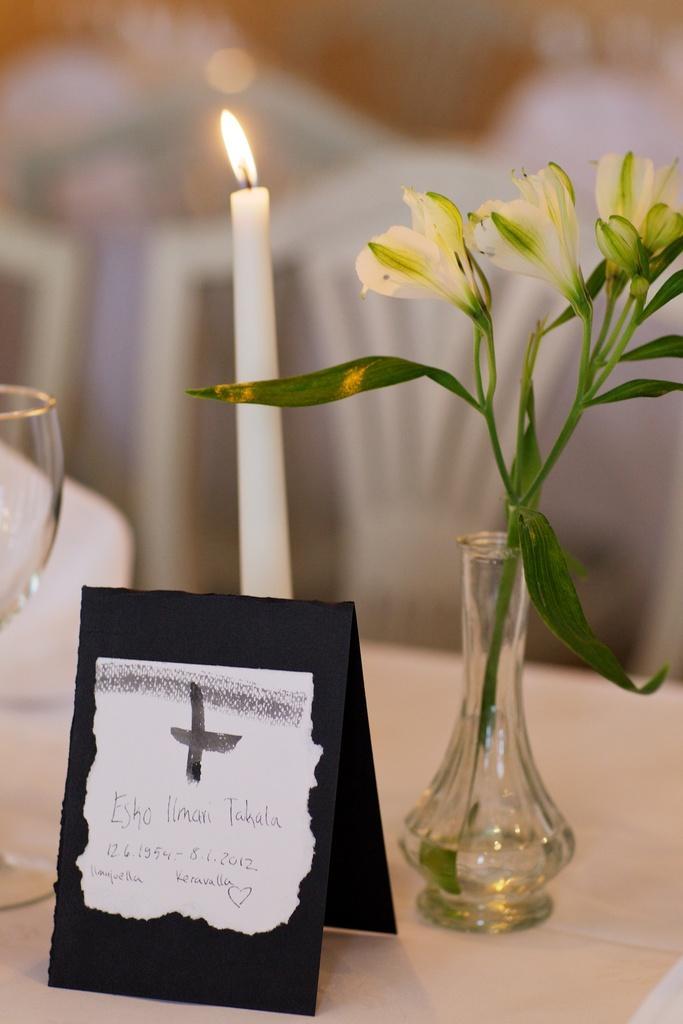Could you give a brief overview of what you see in this image? In this picture there is a white candle a flower placed in a glass pot and a glass and a label placed on top of a table. 